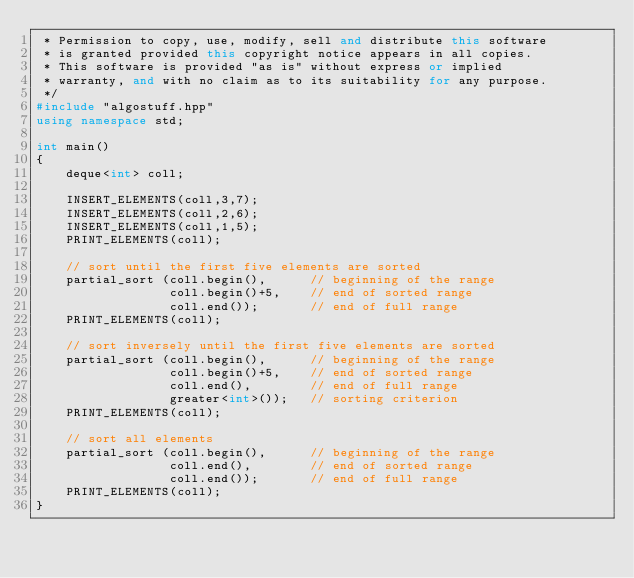Convert code to text. <code><loc_0><loc_0><loc_500><loc_500><_C++_> * Permission to copy, use, modify, sell and distribute this software
 * is granted provided this copyright notice appears in all copies.
 * This software is provided "as is" without express or implied
 * warranty, and with no claim as to its suitability for any purpose.
 */
#include "algostuff.hpp"
using namespace std;

int main()
{
    deque<int> coll;

    INSERT_ELEMENTS(coll,3,7);
    INSERT_ELEMENTS(coll,2,6);
    INSERT_ELEMENTS(coll,1,5);
    PRINT_ELEMENTS(coll);

    // sort until the first five elements are sorted
    partial_sort (coll.begin(),      // beginning of the range
                  coll.begin()+5,    // end of sorted range
                  coll.end());       // end of full range
    PRINT_ELEMENTS(coll);

    // sort inversely until the first five elements are sorted
    partial_sort (coll.begin(),      // beginning of the range
                  coll.begin()+5,    // end of sorted range
                  coll.end(),        // end of full range
                  greater<int>());   // sorting criterion
    PRINT_ELEMENTS(coll);

    // sort all elements
    partial_sort (coll.begin(),      // beginning of the range
                  coll.end(),        // end of sorted range
                  coll.end());       // end of full range
    PRINT_ELEMENTS(coll);
}
</code> 